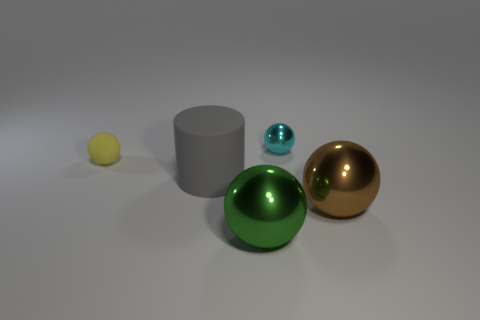Add 1 green objects. How many objects exist? 6 Subtract all balls. How many objects are left? 1 Add 2 gray rubber spheres. How many gray rubber spheres exist? 2 Subtract 0 green cylinders. How many objects are left? 5 Subtract all large red matte things. Subtract all cyan balls. How many objects are left? 4 Add 3 cyan balls. How many cyan balls are left? 4 